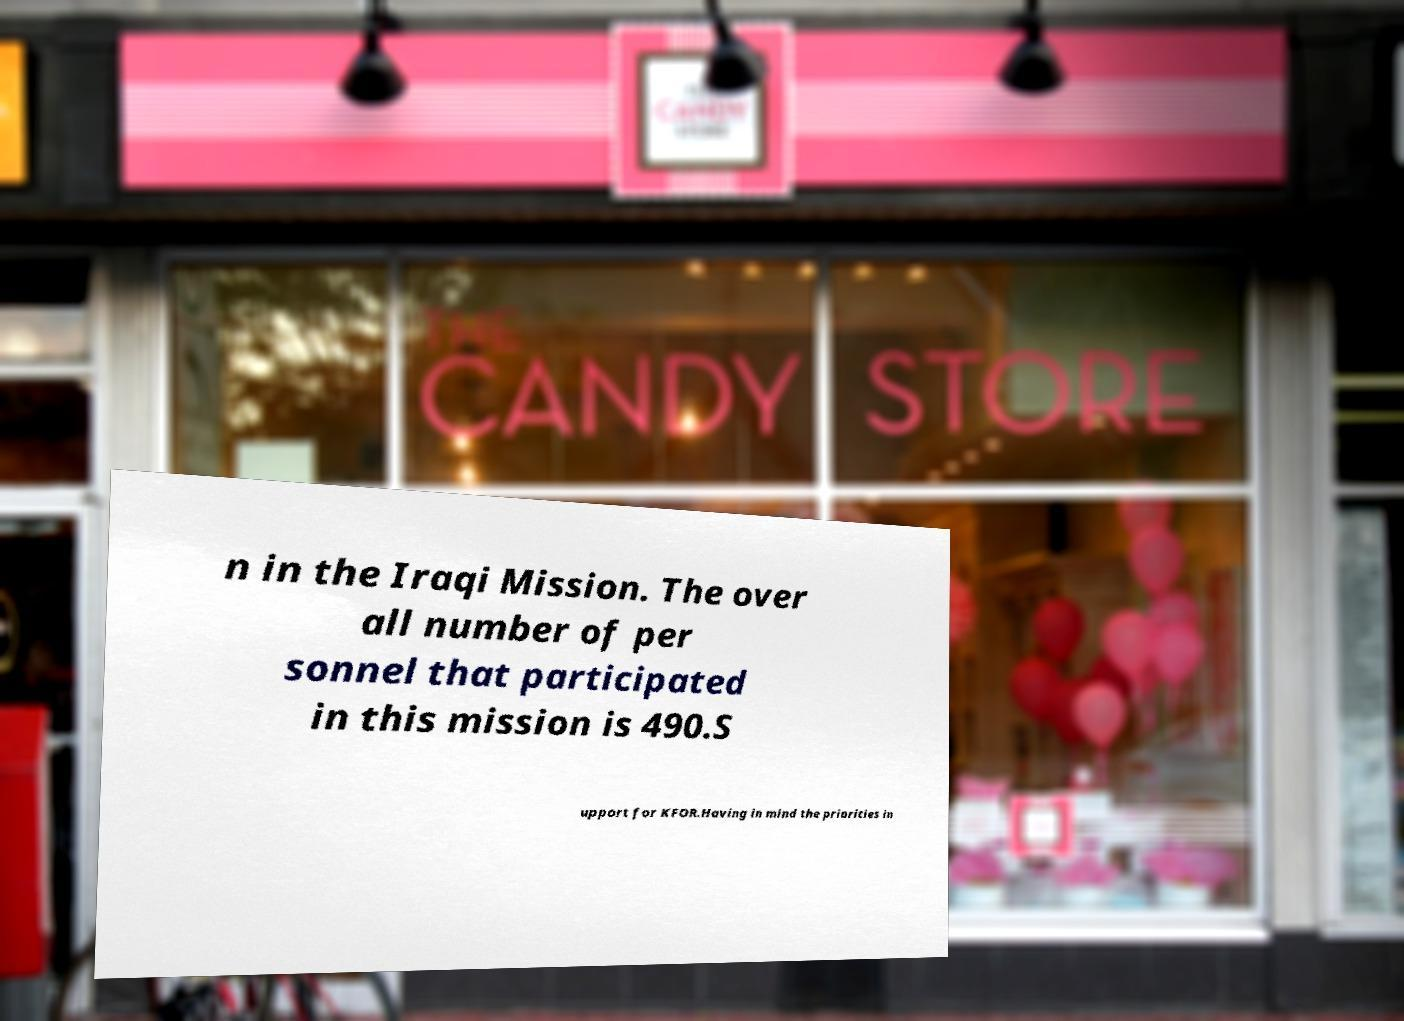Can you accurately transcribe the text from the provided image for me? n in the Iraqi Mission. The over all number of per sonnel that participated in this mission is 490.S upport for KFOR.Having in mind the priorities in 